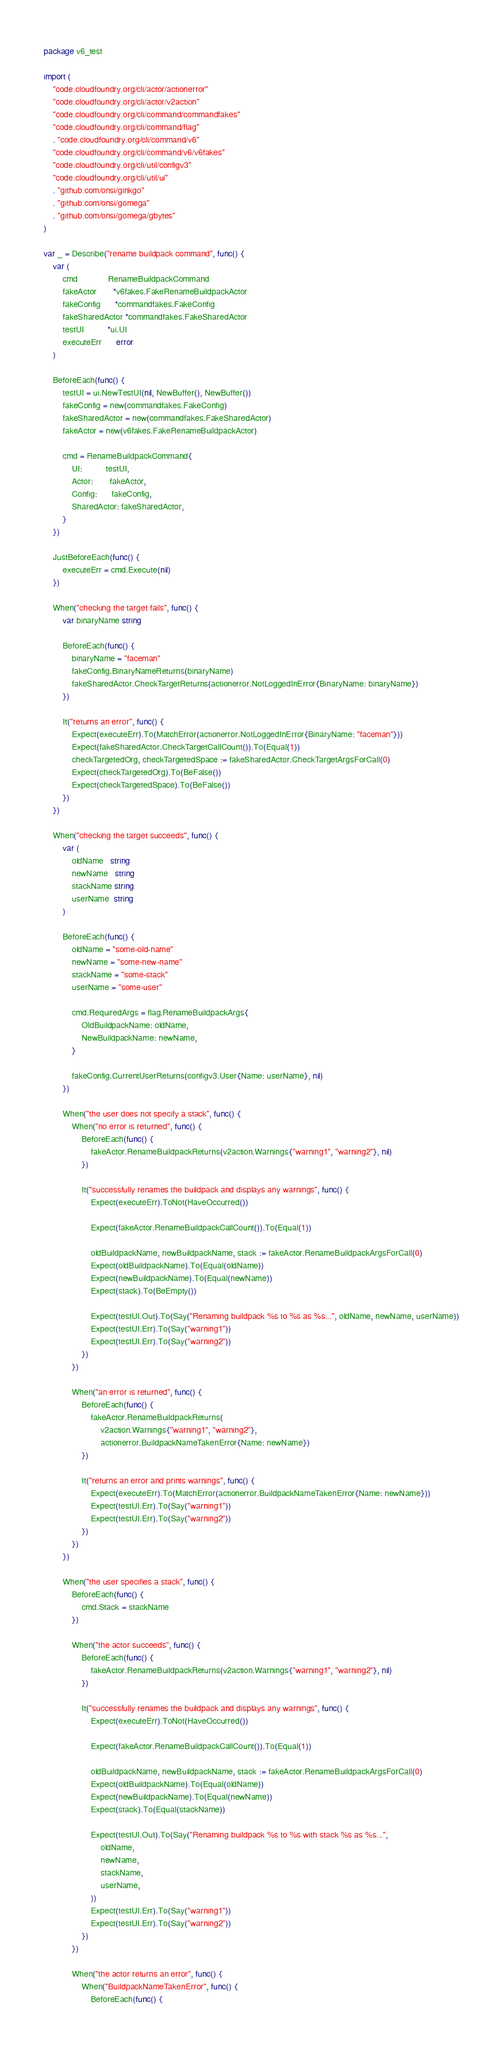<code> <loc_0><loc_0><loc_500><loc_500><_Go_>package v6_test

import (
	"code.cloudfoundry.org/cli/actor/actionerror"
	"code.cloudfoundry.org/cli/actor/v2action"
	"code.cloudfoundry.org/cli/command/commandfakes"
	"code.cloudfoundry.org/cli/command/flag"
	. "code.cloudfoundry.org/cli/command/v6"
	"code.cloudfoundry.org/cli/command/v6/v6fakes"
	"code.cloudfoundry.org/cli/util/configv3"
	"code.cloudfoundry.org/cli/util/ui"
	. "github.com/onsi/ginkgo"
	. "github.com/onsi/gomega"
	. "github.com/onsi/gomega/gbytes"
)

var _ = Describe("rename buildpack command", func() {
	var (
		cmd             RenameBuildpackCommand
		fakeActor       *v6fakes.FakeRenameBuildpackActor
		fakeConfig      *commandfakes.FakeConfig
		fakeSharedActor *commandfakes.FakeSharedActor
		testUI          *ui.UI
		executeErr      error
	)

	BeforeEach(func() {
		testUI = ui.NewTestUI(nil, NewBuffer(), NewBuffer())
		fakeConfig = new(commandfakes.FakeConfig)
		fakeSharedActor = new(commandfakes.FakeSharedActor)
		fakeActor = new(v6fakes.FakeRenameBuildpackActor)

		cmd = RenameBuildpackCommand{
			UI:          testUI,
			Actor:       fakeActor,
			Config:      fakeConfig,
			SharedActor: fakeSharedActor,
		}
	})

	JustBeforeEach(func() {
		executeErr = cmd.Execute(nil)
	})

	When("checking the target fails", func() {
		var binaryName string

		BeforeEach(func() {
			binaryName = "faceman"
			fakeConfig.BinaryNameReturns(binaryName)
			fakeSharedActor.CheckTargetReturns(actionerror.NotLoggedInError{BinaryName: binaryName})
		})

		It("returns an error", func() {
			Expect(executeErr).To(MatchError(actionerror.NotLoggedInError{BinaryName: "faceman"}))
			Expect(fakeSharedActor.CheckTargetCallCount()).To(Equal(1))
			checkTargetedOrg, checkTargetedSpace := fakeSharedActor.CheckTargetArgsForCall(0)
			Expect(checkTargetedOrg).To(BeFalse())
			Expect(checkTargetedSpace).To(BeFalse())
		})
	})

	When("checking the target succeeds", func() {
		var (
			oldName   string
			newName   string
			stackName string
			userName  string
		)

		BeforeEach(func() {
			oldName = "some-old-name"
			newName = "some-new-name"
			stackName = "some-stack"
			userName = "some-user"

			cmd.RequiredArgs = flag.RenameBuildpackArgs{
				OldBuildpackName: oldName,
				NewBuildpackName: newName,
			}

			fakeConfig.CurrentUserReturns(configv3.User{Name: userName}, nil)
		})

		When("the user does not specify a stack", func() {
			When("no error is returned", func() {
				BeforeEach(func() {
					fakeActor.RenameBuildpackReturns(v2action.Warnings{"warning1", "warning2"}, nil)
				})

				It("successfully renames the buildpack and displays any warnings", func() {
					Expect(executeErr).ToNot(HaveOccurred())

					Expect(fakeActor.RenameBuildpackCallCount()).To(Equal(1))

					oldBuildpackName, newBuildpackName, stack := fakeActor.RenameBuildpackArgsForCall(0)
					Expect(oldBuildpackName).To(Equal(oldName))
					Expect(newBuildpackName).To(Equal(newName))
					Expect(stack).To(BeEmpty())

					Expect(testUI.Out).To(Say("Renaming buildpack %s to %s as %s...", oldName, newName, userName))
					Expect(testUI.Err).To(Say("warning1"))
					Expect(testUI.Err).To(Say("warning2"))
				})
			})

			When("an error is returned", func() {
				BeforeEach(func() {
					fakeActor.RenameBuildpackReturns(
						v2action.Warnings{"warning1", "warning2"},
						actionerror.BuildpackNameTakenError{Name: newName})
				})

				It("returns an error and prints warnings", func() {
					Expect(executeErr).To(MatchError(actionerror.BuildpackNameTakenError{Name: newName}))
					Expect(testUI.Err).To(Say("warning1"))
					Expect(testUI.Err).To(Say("warning2"))
				})
			})
		})

		When("the user specifies a stack", func() {
			BeforeEach(func() {
				cmd.Stack = stackName
			})

			When("the actor succeeds", func() {
				BeforeEach(func() {
					fakeActor.RenameBuildpackReturns(v2action.Warnings{"warning1", "warning2"}, nil)
				})

				It("successfully renames the buildpack and displays any warnings", func() {
					Expect(executeErr).ToNot(HaveOccurred())

					Expect(fakeActor.RenameBuildpackCallCount()).To(Equal(1))

					oldBuildpackName, newBuildpackName, stack := fakeActor.RenameBuildpackArgsForCall(0)
					Expect(oldBuildpackName).To(Equal(oldName))
					Expect(newBuildpackName).To(Equal(newName))
					Expect(stack).To(Equal(stackName))

					Expect(testUI.Out).To(Say("Renaming buildpack %s to %s with stack %s as %s...",
						oldName,
						newName,
						stackName,
						userName,
					))
					Expect(testUI.Err).To(Say("warning1"))
					Expect(testUI.Err).To(Say("warning2"))
				})
			})

			When("the actor returns an error", func() {
				When("BuildpackNameTakenError", func() {
					BeforeEach(func() {</code> 